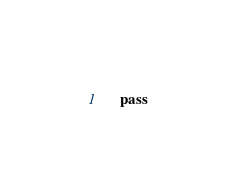Convert code to text. <code><loc_0><loc_0><loc_500><loc_500><_Python_>    pass
</code> 